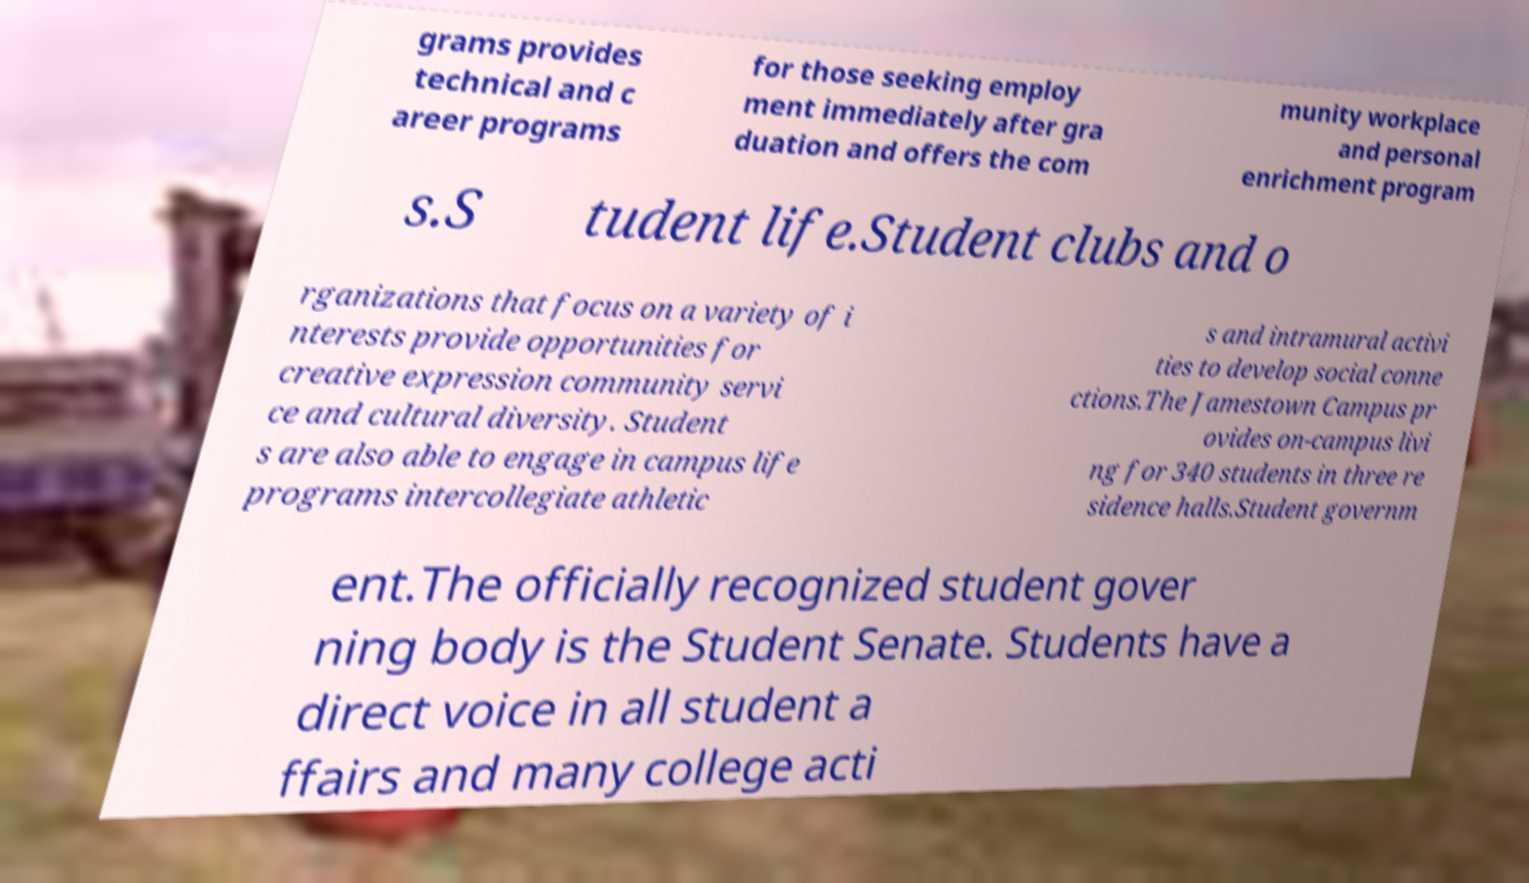What messages or text are displayed in this image? I need them in a readable, typed format. grams provides technical and c areer programs for those seeking employ ment immediately after gra duation and offers the com munity workplace and personal enrichment program s.S tudent life.Student clubs and o rganizations that focus on a variety of i nterests provide opportunities for creative expression community servi ce and cultural diversity. Student s are also able to engage in campus life programs intercollegiate athletic s and intramural activi ties to develop social conne ctions.The Jamestown Campus pr ovides on-campus livi ng for 340 students in three re sidence halls.Student governm ent.The officially recognized student gover ning body is the Student Senate. Students have a direct voice in all student a ffairs and many college acti 